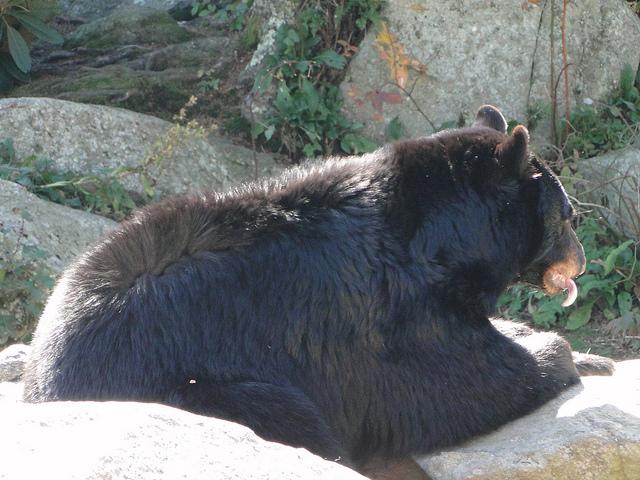Is the bear eating peanuts?
Answer briefly. No. Are there any plants in between the rocks?
Short answer required. Yes. What color is this bear?
Answer briefly. Black. Does this bear look lonely?
Give a very brief answer. Yes. What animal is shown here?
Concise answer only. Bear. How old is the bear?
Be succinct. Adult. What color is the bear?
Be succinct. Black. What is in the bear's mouth?
Quick response, please. Fish. Are there trees behind the bear?
Quick response, please. No. What is the bear eating?
Be succinct. Fish. Is the bear fighting?
Write a very short answer. No. Is the bear eating?
Give a very brief answer. Yes. 